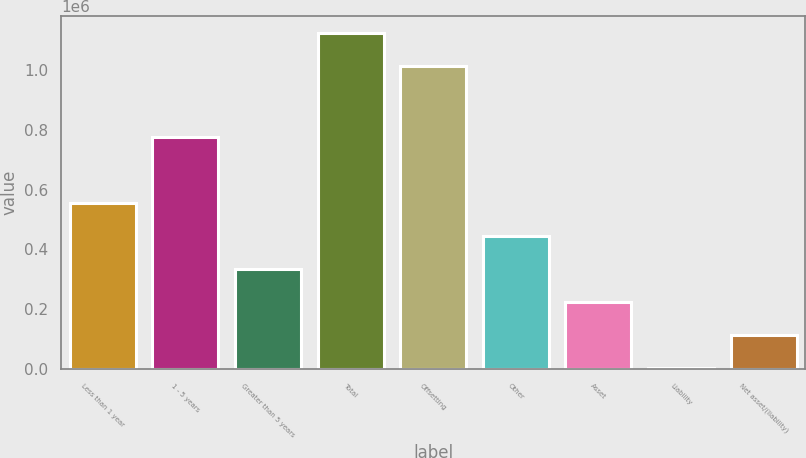<chart> <loc_0><loc_0><loc_500><loc_500><bar_chart><fcel>Less than 1 year<fcel>1 - 5 years<fcel>Greater than 5 years<fcel>Total<fcel>Offsetting<fcel>Other<fcel>Asset<fcel>Liability<fcel>Net asset/(liability)<nl><fcel>554917<fcel>775784<fcel>334402<fcel>1.12313e+06<fcel>1.01287e+06<fcel>444659<fcel>224144<fcel>3629<fcel>113887<nl></chart> 